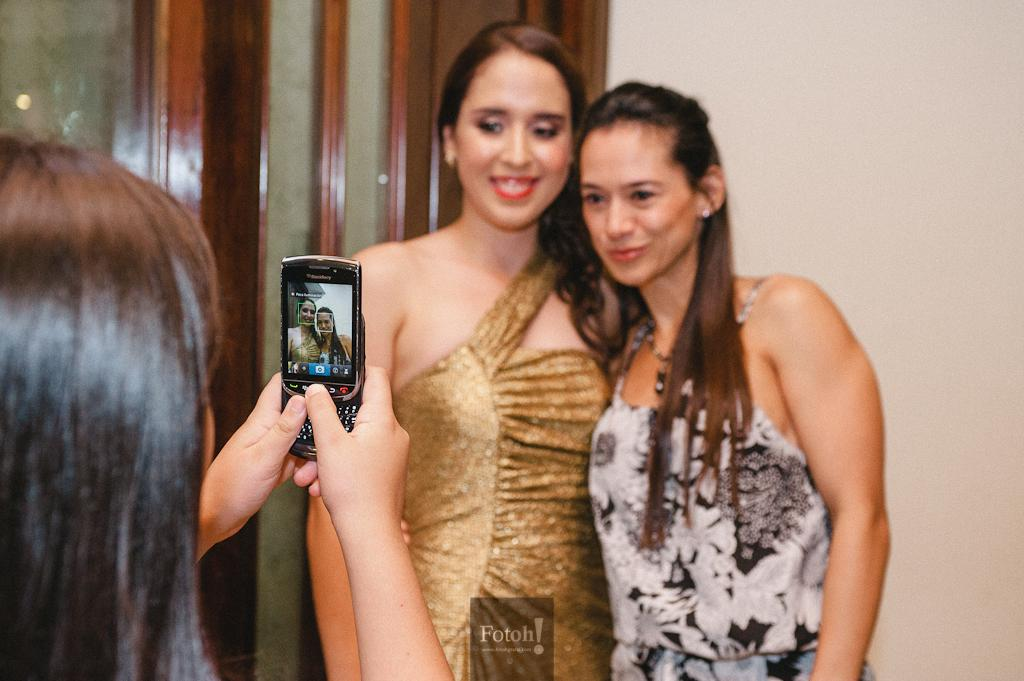How many women are present in the image? There are three women standing in the image. What is one of the women holding? One of the women is holding a mobile phone. What can be seen in the background of the image? There is a door and a wall visible in the background of the image. What is the purpose of the icicle hanging from the wall in the image? There is no icicle present in the image; it is not mentioned in the provided facts. 